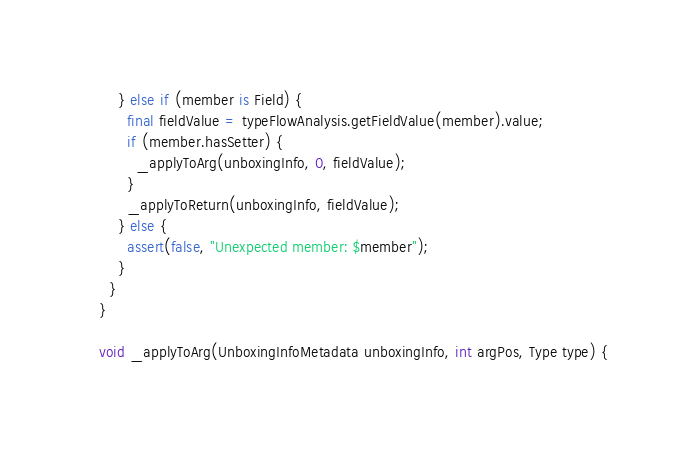Convert code to text. <code><loc_0><loc_0><loc_500><loc_500><_Dart_>      } else if (member is Field) {
        final fieldValue = typeFlowAnalysis.getFieldValue(member).value;
        if (member.hasSetter) {
          _applyToArg(unboxingInfo, 0, fieldValue);
        }
        _applyToReturn(unboxingInfo, fieldValue);
      } else {
        assert(false, "Unexpected member: $member");
      }
    }
  }

  void _applyToArg(UnboxingInfoMetadata unboxingInfo, int argPos, Type type) {</code> 